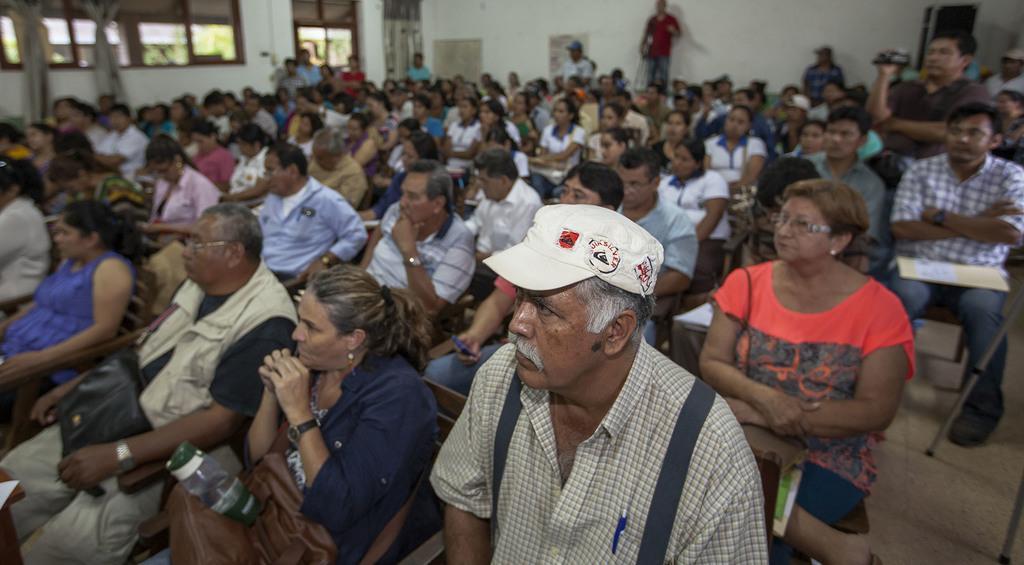Describe this image in one or two sentences. In this image we can see some people are sitting on the chairs, some curtains, some people are holding some objects, some trees on the ground, some glass windows, some people are standing near the wall, one door, some objects attached to the wall, one man with cap standing and taking a video. 